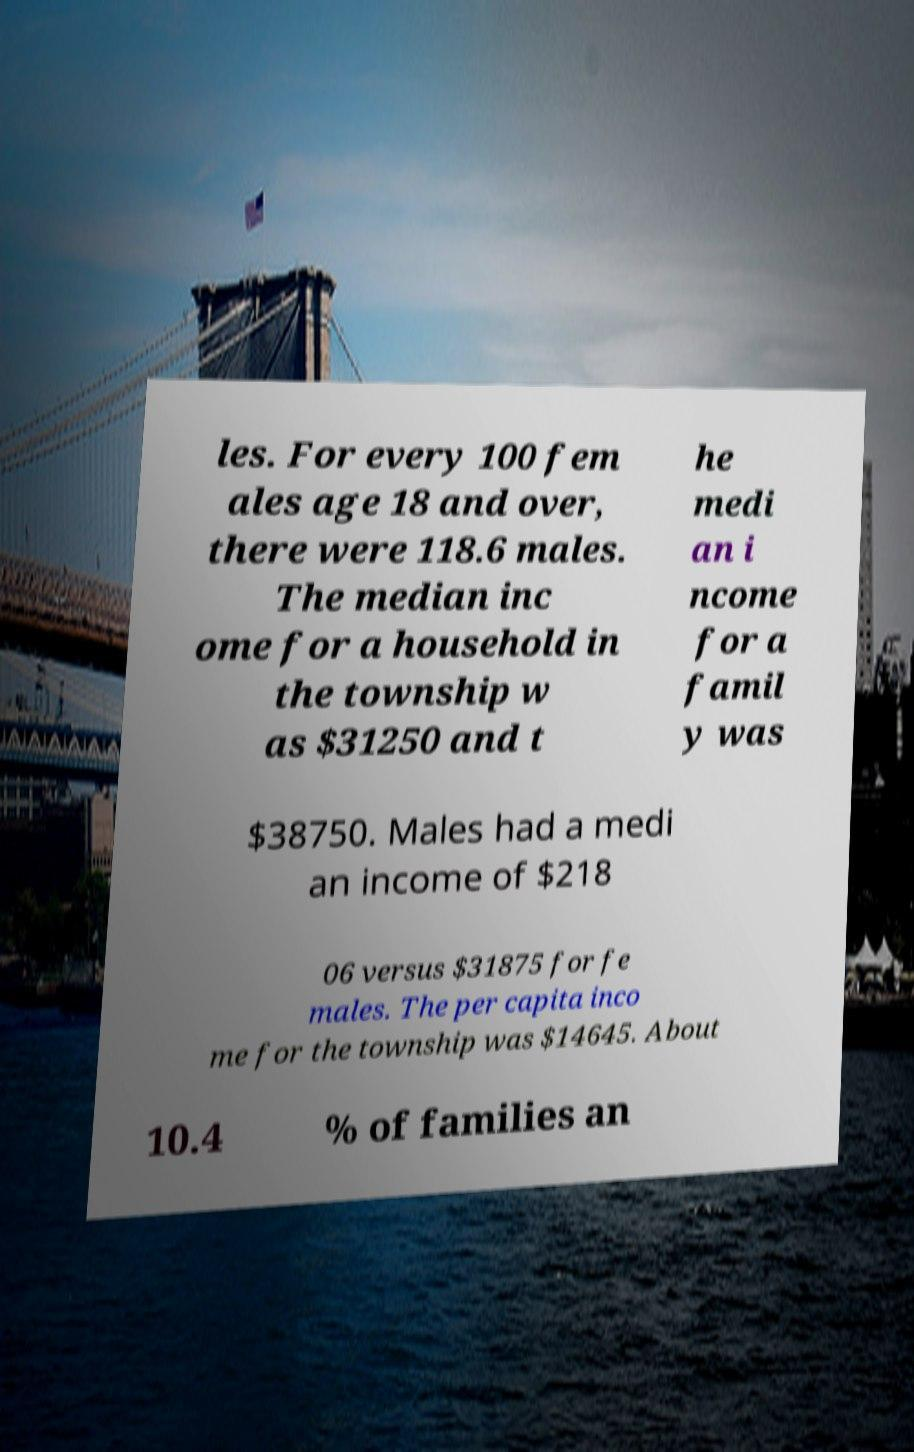Can you read and provide the text displayed in the image?This photo seems to have some interesting text. Can you extract and type it out for me? les. For every 100 fem ales age 18 and over, there were 118.6 males. The median inc ome for a household in the township w as $31250 and t he medi an i ncome for a famil y was $38750. Males had a medi an income of $218 06 versus $31875 for fe males. The per capita inco me for the township was $14645. About 10.4 % of families an 